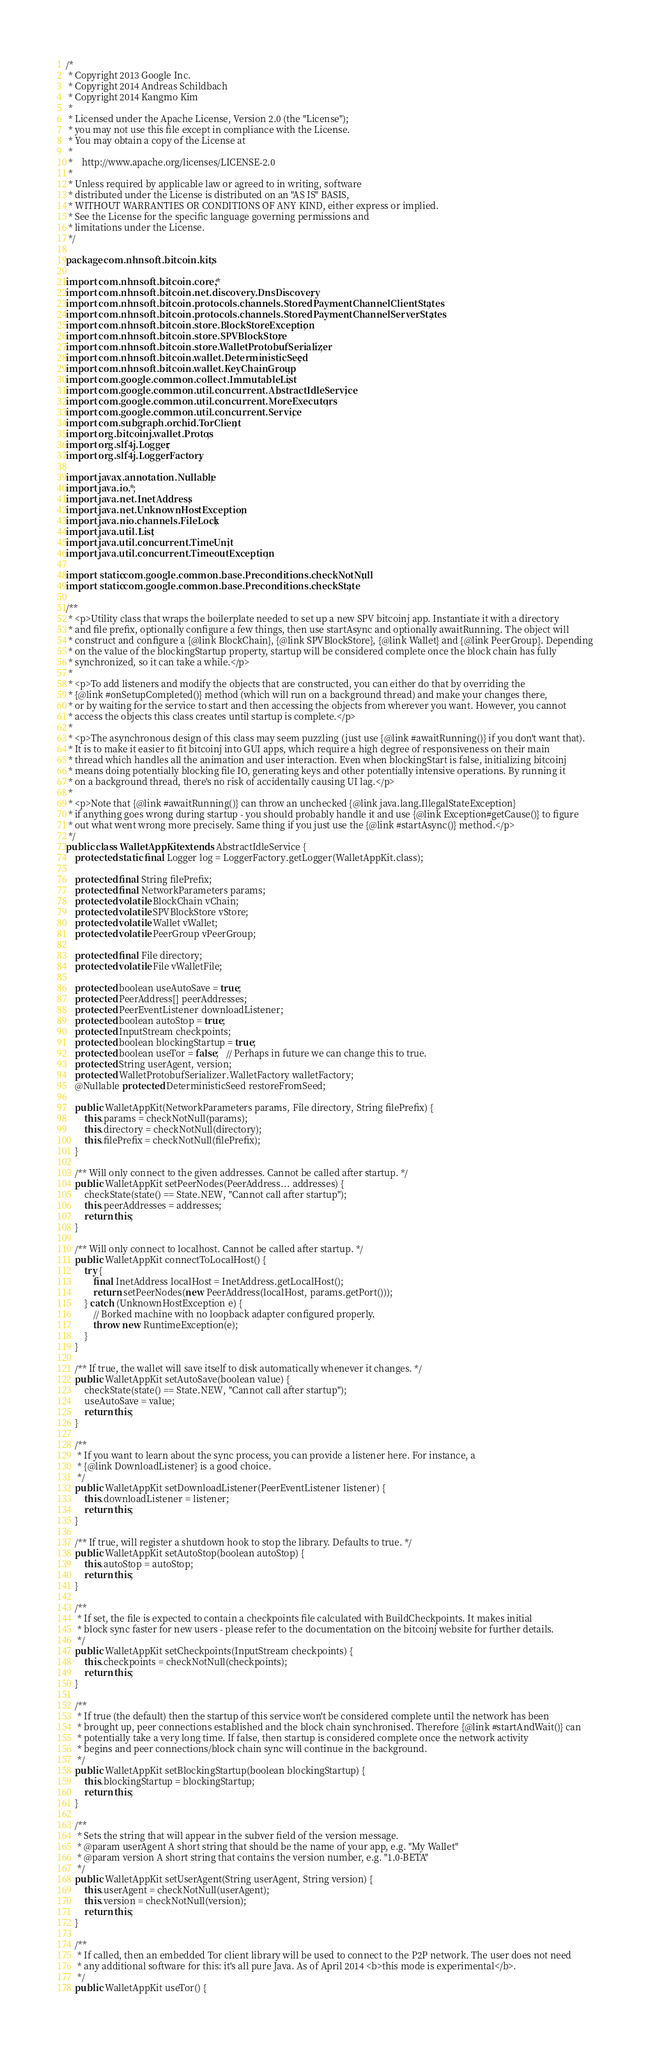Convert code to text. <code><loc_0><loc_0><loc_500><loc_500><_Java_>/*
 * Copyright 2013 Google Inc.
 * Copyright 2014 Andreas Schildbach
 * Copyright 2014 Kangmo Kim 
 *
 * Licensed under the Apache License, Version 2.0 (the "License");
 * you may not use this file except in compliance with the License.
 * You may obtain a copy of the License at
 *
 *    http://www.apache.org/licenses/LICENSE-2.0
 *
 * Unless required by applicable law or agreed to in writing, software
 * distributed under the License is distributed on an "AS IS" BASIS,
 * WITHOUT WARRANTIES OR CONDITIONS OF ANY KIND, either express or implied.
 * See the License for the specific language governing permissions and
 * limitations under the License.
 */

package com.nhnsoft.bitcoin.kits;

import com.nhnsoft.bitcoin.core.*;
import com.nhnsoft.bitcoin.net.discovery.DnsDiscovery;
import com.nhnsoft.bitcoin.protocols.channels.StoredPaymentChannelClientStates;
import com.nhnsoft.bitcoin.protocols.channels.StoredPaymentChannelServerStates;
import com.nhnsoft.bitcoin.store.BlockStoreException;
import com.nhnsoft.bitcoin.store.SPVBlockStore;
import com.nhnsoft.bitcoin.store.WalletProtobufSerializer;
import com.nhnsoft.bitcoin.wallet.DeterministicSeed;
import com.nhnsoft.bitcoin.wallet.KeyChainGroup;
import com.google.common.collect.ImmutableList;
import com.google.common.util.concurrent.AbstractIdleService;
import com.google.common.util.concurrent.MoreExecutors;
import com.google.common.util.concurrent.Service;
import com.subgraph.orchid.TorClient;
import org.bitcoinj.wallet.Protos;
import org.slf4j.Logger;
import org.slf4j.LoggerFactory;

import javax.annotation.Nullable;
import java.io.*;
import java.net.InetAddress;
import java.net.UnknownHostException;
import java.nio.channels.FileLock;
import java.util.List;
import java.util.concurrent.TimeUnit;
import java.util.concurrent.TimeoutException;

import static com.google.common.base.Preconditions.checkNotNull;
import static com.google.common.base.Preconditions.checkState;

/**
 * <p>Utility class that wraps the boilerplate needed to set up a new SPV bitcoinj app. Instantiate it with a directory
 * and file prefix, optionally configure a few things, then use startAsync and optionally awaitRunning. The object will
 * construct and configure a {@link BlockChain}, {@link SPVBlockStore}, {@link Wallet} and {@link PeerGroup}. Depending
 * on the value of the blockingStartup property, startup will be considered complete once the block chain has fully
 * synchronized, so it can take a while.</p>
 *
 * <p>To add listeners and modify the objects that are constructed, you can either do that by overriding the
 * {@link #onSetupCompleted()} method (which will run on a background thread) and make your changes there,
 * or by waiting for the service to start and then accessing the objects from wherever you want. However, you cannot
 * access the objects this class creates until startup is complete.</p>
 *
 * <p>The asynchronous design of this class may seem puzzling (just use {@link #awaitRunning()} if you don't want that).
 * It is to make it easier to fit bitcoinj into GUI apps, which require a high degree of responsiveness on their main
 * thread which handles all the animation and user interaction. Even when blockingStart is false, initializing bitcoinj
 * means doing potentially blocking file IO, generating keys and other potentially intensive operations. By running it
 * on a background thread, there's no risk of accidentally causing UI lag.</p>
 *
 * <p>Note that {@link #awaitRunning()} can throw an unchecked {@link java.lang.IllegalStateException}
 * if anything goes wrong during startup - you should probably handle it and use {@link Exception#getCause()} to figure
 * out what went wrong more precisely. Same thing if you just use the {@link #startAsync()} method.</p>
 */
public class WalletAppKit extends AbstractIdleService {
    protected static final Logger log = LoggerFactory.getLogger(WalletAppKit.class);

    protected final String filePrefix;
    protected final NetworkParameters params;
    protected volatile BlockChain vChain;
    protected volatile SPVBlockStore vStore;
    protected volatile Wallet vWallet;
    protected volatile PeerGroup vPeerGroup;

    protected final File directory;
    protected volatile File vWalletFile;

    protected boolean useAutoSave = true;
    protected PeerAddress[] peerAddresses;
    protected PeerEventListener downloadListener;
    protected boolean autoStop = true;
    protected InputStream checkpoints;
    protected boolean blockingStartup = true;
    protected boolean useTor = false;   // Perhaps in future we can change this to true.
    protected String userAgent, version;
    protected WalletProtobufSerializer.WalletFactory walletFactory;
    @Nullable protected DeterministicSeed restoreFromSeed;

    public WalletAppKit(NetworkParameters params, File directory, String filePrefix) {
        this.params = checkNotNull(params);
        this.directory = checkNotNull(directory);
        this.filePrefix = checkNotNull(filePrefix);
    }

    /** Will only connect to the given addresses. Cannot be called after startup. */
    public WalletAppKit setPeerNodes(PeerAddress... addresses) {
        checkState(state() == State.NEW, "Cannot call after startup");
        this.peerAddresses = addresses;
        return this;
    }

    /** Will only connect to localhost. Cannot be called after startup. */
    public WalletAppKit connectToLocalHost() {
        try {
            final InetAddress localHost = InetAddress.getLocalHost();
            return setPeerNodes(new PeerAddress(localHost, params.getPort()));
        } catch (UnknownHostException e) {
            // Borked machine with no loopback adapter configured properly.
            throw new RuntimeException(e);
        }
    }

    /** If true, the wallet will save itself to disk automatically whenever it changes. */
    public WalletAppKit setAutoSave(boolean value) {
        checkState(state() == State.NEW, "Cannot call after startup");
        useAutoSave = value;
        return this;
    }

    /**
     * If you want to learn about the sync process, you can provide a listener here. For instance, a
     * {@link DownloadListener} is a good choice.
     */
    public WalletAppKit setDownloadListener(PeerEventListener listener) {
        this.downloadListener = listener;
        return this;
    }

    /** If true, will register a shutdown hook to stop the library. Defaults to true. */
    public WalletAppKit setAutoStop(boolean autoStop) {
        this.autoStop = autoStop;
        return this;
    }

    /**
     * If set, the file is expected to contain a checkpoints file calculated with BuildCheckpoints. It makes initial
     * block sync faster for new users - please refer to the documentation on the bitcoinj website for further details.
     */
    public WalletAppKit setCheckpoints(InputStream checkpoints) {
        this.checkpoints = checkNotNull(checkpoints);
        return this;
    }

    /**
     * If true (the default) then the startup of this service won't be considered complete until the network has been
     * brought up, peer connections established and the block chain synchronised. Therefore {@link #startAndWait()} can
     * potentially take a very long time. If false, then startup is considered complete once the network activity
     * begins and peer connections/block chain sync will continue in the background.
     */
    public WalletAppKit setBlockingStartup(boolean blockingStartup) {
        this.blockingStartup = blockingStartup;
        return this;
    }

    /**
     * Sets the string that will appear in the subver field of the version message.
     * @param userAgent A short string that should be the name of your app, e.g. "My Wallet"
     * @param version A short string that contains the version number, e.g. "1.0-BETA"
     */
    public WalletAppKit setUserAgent(String userAgent, String version) {
        this.userAgent = checkNotNull(userAgent);
        this.version = checkNotNull(version);
        return this;
    }

    /**
     * If called, then an embedded Tor client library will be used to connect to the P2P network. The user does not need
     * any additional software for this: it's all pure Java. As of April 2014 <b>this mode is experimental</b>.
     */
    public WalletAppKit useTor() {</code> 